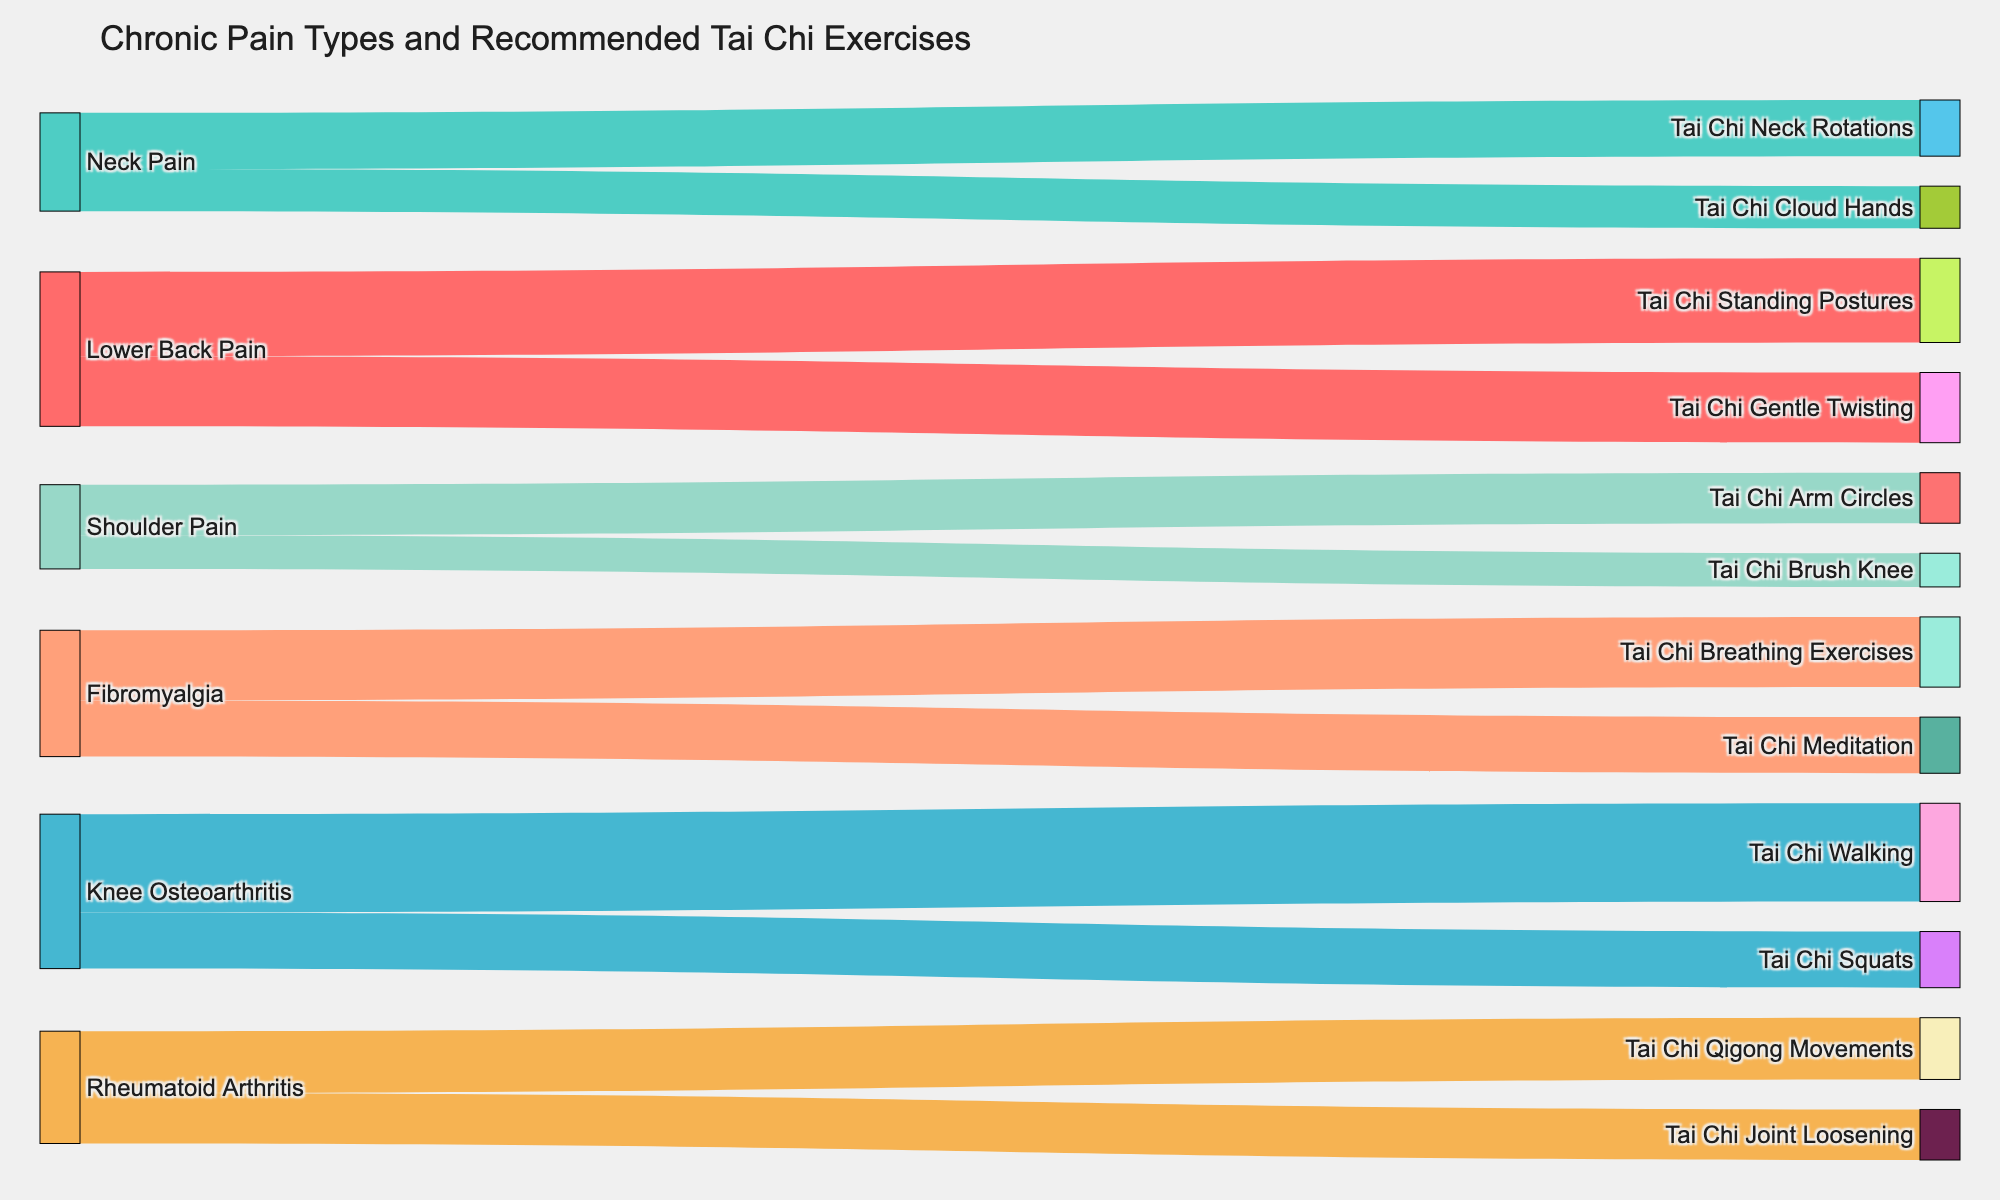Which type of chronic pain has the highest number of Tai Chi exercise recommendations? To determine which type of chronic pain has the highest number of Tai Chi exercise recommendations, we follow the links from each source node (chronic pain) to target nodes (Tai Chi exercises) and sum up the values for each chronic pain type. Lower Back Pain has recommendations of 30 (Tai Chi Standing Postures) and 25 (Tai Chi Gentle Twisting), totaling 55. Knee Osteoarthritis follows closely with 35 (Tai Chi Walking) and 20 (Tai Chi Squats), totaling 55 as well. Both Lower Back Pain and Knee Osteoarthritis have the highest recommendations which is 55.
Answer: Lower Back Pain, Knee Osteoarthritis What is the total number of Tai Chi exercises recommended for patients with Neck Pain? To find the total number of Tai Chi exercises for Neck Pain, sum the values for each corresponding exercise: 20 (Tai Chi Neck Rotations) and 15 (Tai Chi Cloud Hands). Therefore, the total number is 20 + 15 = 35.
Answer: 35 Which pain type has the fewest total recommendations for Tai Chi exercises and what is the total value? To identify the pain type with the fewest recommendations, compare the total values for each pain type. Shoulder Pain has 18 (Tai Chi Arm Circles) and 12 (Tai Chi Brush Knee), totaling 30. This is the smallest total compared to other pain types listed in the figure.
Answer: Shoulder Pain, 30 How many total Tai Chi exercises are recommended for Rheumatoid Arthritis? Summing the values of Tai Chi recommendations for Rheumatoid Arthritis: 22 (Tai Chi Qigong Movements) and 18 (Tai Chi Joint Loosening) yields 22 + 18 = 40.
Answer: 40 Which exercise is recommended the most for patients with Lower Back Pain? Comparing the values for Lower Back Pain exercises, Tai Chi Standing Postures has a value of 30 and Tai Chi Gentle Twisting has a value of 25. Thus, Tai Chi Standing Postures is recommended the most.
Answer: Tai Chi Standing Postures Between Tai Chi Walking and Tai Chi Breathing Exercises, which one is recommended more and by how much? Tai Chi Walking is recommended 35 times for Knee Osteoarthritis. Tai Chi Breathing Exercises is recommended 25 times for Fibromyalgia. The difference is 35 - 25 = 10.
Answer: Tai Chi Walking, 10 How many Tai Chi exercises are recommended for patients with Fibromyalgia? The exercises for Fibromyalgia include Tai Chi Breathing Exercises and Tai Chi Meditation, with values of 25 and 20 respectively. Adding these gives 25 + 20 = 45.
Answer: 45 Does any chronic pain type have equal recommendations for different Tai Chi exercises? Checking each pain type, Rheumatoid Arthritis has Tai Chi Qigong Movements with a value of 22 and Tai Chi Joint Loosening with a value of 18, which are not equal. Similarly, all other pain types have different values for their exercise recommendations.
Answer: No What is the average number of Tai Chi exercise recommendations for Knee Osteoarthritis? The recommendations for Knee Osteoarthritis are 35 for Tai Chi Walking and 20 for Tai Chi Squats. The average is (35 + 20) / 2 = 27.5.
Answer: 27.5 